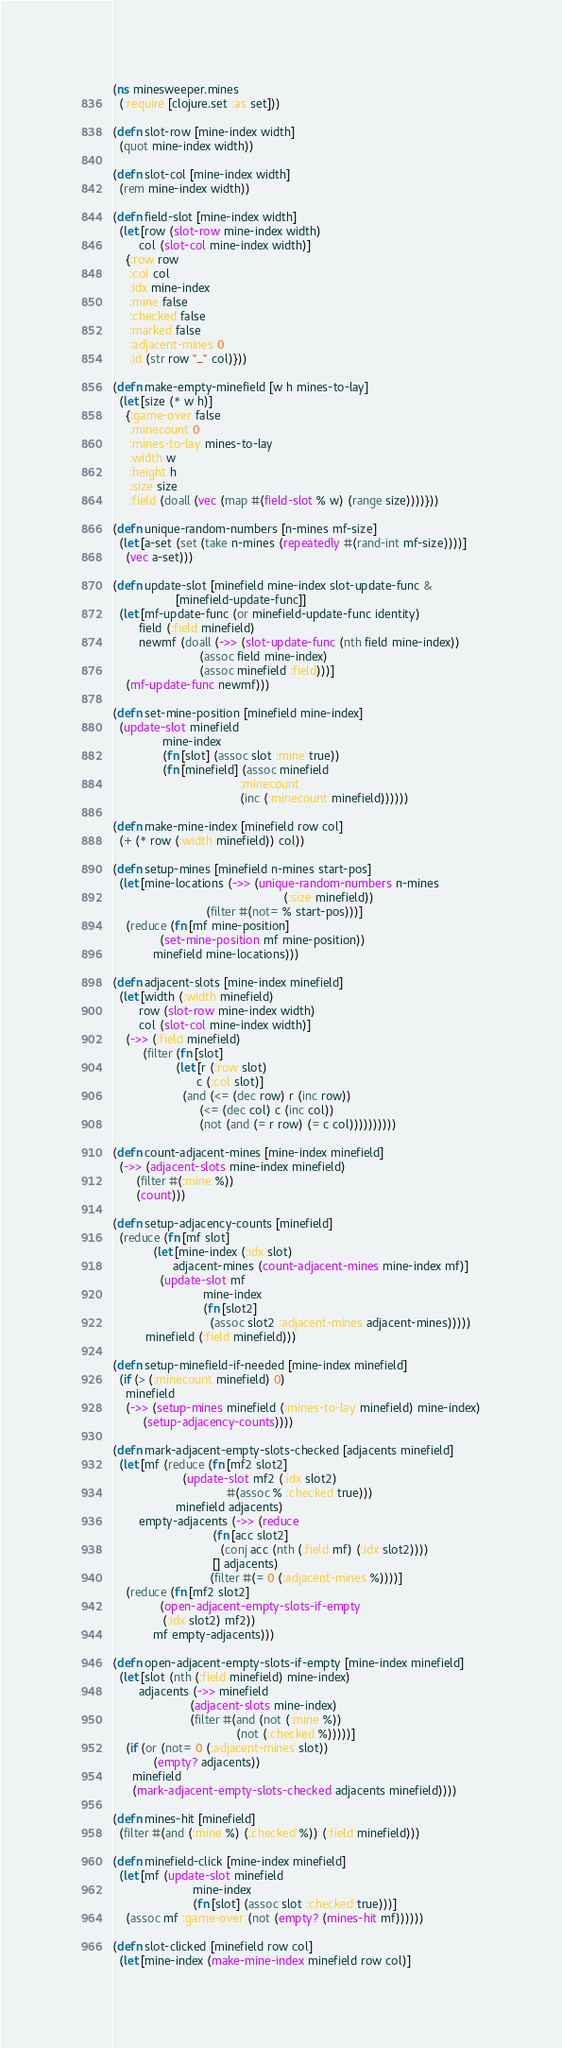Convert code to text. <code><loc_0><loc_0><loc_500><loc_500><_Clojure_>(ns minesweeper.mines
  (:require [clojure.set :as set]))

(defn slot-row [mine-index width]
  (quot mine-index width))

(defn slot-col [mine-index width]
  (rem mine-index width))

(defn field-slot [mine-index width]
  (let [row (slot-row mine-index width)
        col (slot-col mine-index width)]
    {:row row
     :col col
     :idx mine-index
     :mine false
     :checked false
     :marked false
     :adjacent-mines 0
     :id (str row "_" col)}))

(defn make-empty-minefield [w h mines-to-lay]
  (let [size (* w h)]
    {:game-over false
     :minecount 0
     :mines-to-lay mines-to-lay
     :width w
     :height h
     :size size
     :field (doall (vec (map #(field-slot % w) (range size))))}))

(defn unique-random-numbers [n-mines mf-size]
  (let [a-set (set (take n-mines (repeatedly #(rand-int mf-size))))]
    (vec a-set)))

(defn update-slot [minefield mine-index slot-update-func &
                   [minefield-update-func]]
  (let [mf-update-func (or minefield-update-func identity)
        field (:field minefield)
        newmf (doall (->> (slot-update-func (nth field mine-index))
                          (assoc field mine-index)
                          (assoc minefield :field)))]
    (mf-update-func newmf)))

(defn set-mine-position [minefield mine-index]
  (update-slot minefield
               mine-index
               (fn [slot] (assoc slot :mine true))
               (fn [minefield] (assoc minefield
                                      :minecount
                                      (inc (:minecount minefield))))))

(defn make-mine-index [minefield row col]
  (+ (* row (:width minefield)) col))

(defn setup-mines [minefield n-mines start-pos]
  (let [mine-locations (->> (unique-random-numbers n-mines
                                                   (:size minefield))
                            (filter #(not= % start-pos)))]
    (reduce (fn [mf mine-position]
              (set-mine-position mf mine-position))
            minefield mine-locations)))

(defn adjacent-slots [mine-index minefield]
  (let [width (:width minefield)
        row (slot-row mine-index width)
        col (slot-col mine-index width)]
    (->> (:field minefield)
         (filter (fn [slot]
                   (let [r (:row slot)
                         c (:col slot)]
                     (and (<= (dec row) r (inc row))
                          (<= (dec col) c (inc col))
                          (not (and (= r row) (= c col))))))))))

(defn count-adjacent-mines [mine-index minefield]
  (->> (adjacent-slots mine-index minefield)
       (filter #(:mine %))
       (count)))

(defn setup-adjacency-counts [minefield]
  (reduce (fn [mf slot]
            (let [mine-index (:idx slot)
                  adjacent-mines (count-adjacent-mines mine-index mf)]
              (update-slot mf
                           mine-index
                           (fn [slot2]
                             (assoc slot2 :adjacent-mines adjacent-mines)))))
          minefield (:field minefield)))

(defn setup-minefield-if-needed [mine-index minefield]
  (if (> (:minecount minefield) 0)
    minefield
    (->> (setup-mines minefield (:mines-to-lay minefield) mine-index)
         (setup-adjacency-counts))))

(defn mark-adjacent-empty-slots-checked [adjacents minefield]
  (let [mf (reduce (fn [mf2 slot2]
                     (update-slot mf2 (:idx slot2)
                                  #(assoc % :checked true)))
                   minefield adjacents)
        empty-adjacents (->> (reduce
                              (fn [acc slot2]
                                (conj acc (nth (:field mf) (:idx slot2))))
                              [] adjacents)
                             (filter #(= 0 (:adjacent-mines %))))]
    (reduce (fn [mf2 slot2]
              (open-adjacent-empty-slots-if-empty
               (:idx slot2) mf2))
            mf empty-adjacents)))

(defn open-adjacent-empty-slots-if-empty [mine-index minefield]
  (let [slot (nth (:field minefield) mine-index)
        adjacents (->> minefield
                       (adjacent-slots mine-index)
                       (filter #(and (not (:mine %))
                                     (not (:checked %)))))]
    (if (or (not= 0 (:adjacent-mines slot))
            (empty? adjacents))
      minefield
      (mark-adjacent-empty-slots-checked adjacents minefield))))

(defn mines-hit [minefield]
  (filter #(and (:mine %) (:checked %)) (:field minefield)))

(defn minefield-click [mine-index minefield]
  (let [mf (update-slot minefield
                        mine-index
                        (fn [slot] (assoc slot :checked true)))]
    (assoc mf :game-over (not (empty? (mines-hit mf))))))

(defn slot-clicked [minefield row col]
  (let [mine-index (make-mine-index minefield row col)]</code> 